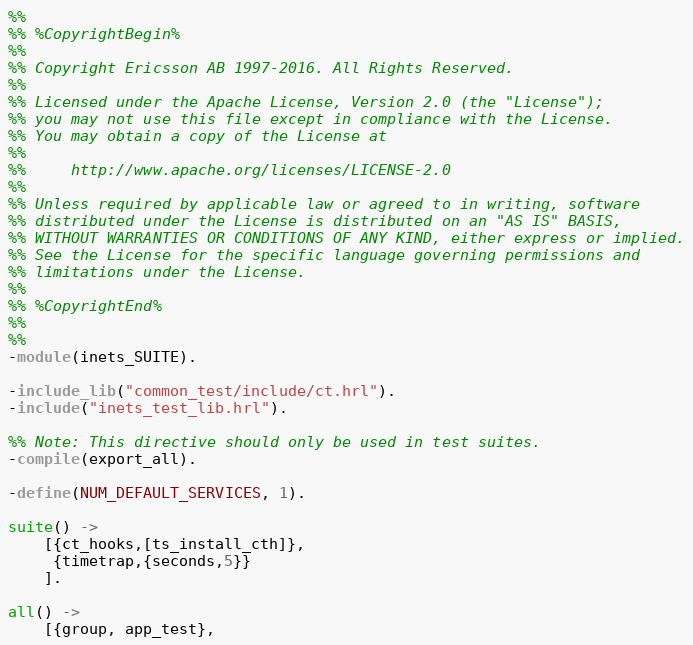<code> <loc_0><loc_0><loc_500><loc_500><_Erlang_>%%
%% %CopyrightBegin%
%%
%% Copyright Ericsson AB 1997-2016. All Rights Reserved.
%%
%% Licensed under the Apache License, Version 2.0 (the "License");
%% you may not use this file except in compliance with the License.
%% You may obtain a copy of the License at
%%
%%     http://www.apache.org/licenses/LICENSE-2.0
%%
%% Unless required by applicable law or agreed to in writing, software
%% distributed under the License is distributed on an "AS IS" BASIS,
%% WITHOUT WARRANTIES OR CONDITIONS OF ANY KIND, either express or implied.
%% See the License for the specific language governing permissions and
%% limitations under the License.
%%
%% %CopyrightEnd%
%%
%%
-module(inets_SUITE).

-include_lib("common_test/include/ct.hrl").
-include("inets_test_lib.hrl").

%% Note: This directive should only be used in test suites.
-compile(export_all).

-define(NUM_DEFAULT_SERVICES, 1).

suite() -> 
    [{ct_hooks,[ts_install_cth]},
     {timetrap,{seconds,5}}
    ].

all() -> 
    [{group, app_test}, </code> 